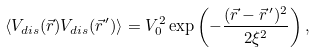<formula> <loc_0><loc_0><loc_500><loc_500>\langle V _ { d i s } ( \vec { r } ) V _ { d i s } ( \vec { r } ^ { \, \prime } ) \rangle = V _ { 0 } ^ { 2 } \exp \left ( - \frac { ( \vec { r } - \vec { r } ^ { \, \prime } ) ^ { 2 } } { 2 \xi ^ { 2 } } \right ) ,</formula> 